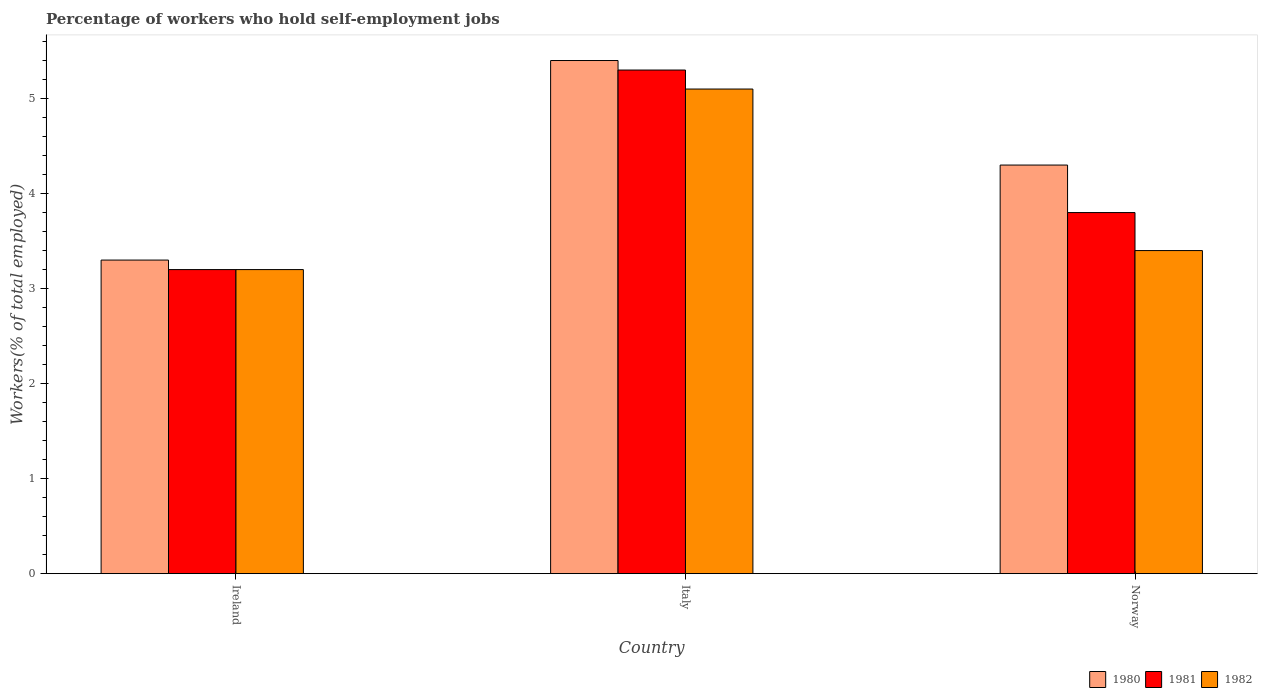Are the number of bars on each tick of the X-axis equal?
Offer a terse response. Yes. What is the label of the 3rd group of bars from the left?
Provide a succinct answer. Norway. In how many cases, is the number of bars for a given country not equal to the number of legend labels?
Keep it short and to the point. 0. What is the percentage of self-employed workers in 1982 in Italy?
Offer a terse response. 5.1. Across all countries, what is the maximum percentage of self-employed workers in 1980?
Keep it short and to the point. 5.4. Across all countries, what is the minimum percentage of self-employed workers in 1980?
Give a very brief answer. 3.3. In which country was the percentage of self-employed workers in 1982 maximum?
Your answer should be very brief. Italy. In which country was the percentage of self-employed workers in 1981 minimum?
Provide a short and direct response. Ireland. What is the total percentage of self-employed workers in 1982 in the graph?
Give a very brief answer. 11.7. What is the difference between the percentage of self-employed workers in 1981 in Ireland and that in Italy?
Provide a short and direct response. -2.1. What is the difference between the percentage of self-employed workers in 1981 in Ireland and the percentage of self-employed workers in 1980 in Norway?
Offer a very short reply. -1.1. What is the average percentage of self-employed workers in 1982 per country?
Your response must be concise. 3.9. What is the difference between the percentage of self-employed workers of/in 1980 and percentage of self-employed workers of/in 1981 in Norway?
Make the answer very short. 0.5. In how many countries, is the percentage of self-employed workers in 1981 greater than 0.6000000000000001 %?
Your response must be concise. 3. What is the ratio of the percentage of self-employed workers in 1980 in Ireland to that in Norway?
Offer a very short reply. 0.77. Is the percentage of self-employed workers in 1982 in Ireland less than that in Norway?
Provide a short and direct response. Yes. Is the difference between the percentage of self-employed workers in 1980 in Italy and Norway greater than the difference between the percentage of self-employed workers in 1981 in Italy and Norway?
Make the answer very short. No. What is the difference between the highest and the second highest percentage of self-employed workers in 1980?
Your answer should be compact. -1. What is the difference between the highest and the lowest percentage of self-employed workers in 1982?
Offer a terse response. 1.9. What does the 2nd bar from the right in Italy represents?
Your response must be concise. 1981. Is it the case that in every country, the sum of the percentage of self-employed workers in 1981 and percentage of self-employed workers in 1982 is greater than the percentage of self-employed workers in 1980?
Provide a succinct answer. Yes. How many countries are there in the graph?
Provide a succinct answer. 3. Are the values on the major ticks of Y-axis written in scientific E-notation?
Your answer should be compact. No. Does the graph contain any zero values?
Provide a short and direct response. No. How many legend labels are there?
Your answer should be compact. 3. How are the legend labels stacked?
Give a very brief answer. Horizontal. What is the title of the graph?
Provide a succinct answer. Percentage of workers who hold self-employment jobs. What is the label or title of the X-axis?
Your response must be concise. Country. What is the label or title of the Y-axis?
Keep it short and to the point. Workers(% of total employed). What is the Workers(% of total employed) in 1980 in Ireland?
Ensure brevity in your answer.  3.3. What is the Workers(% of total employed) of 1981 in Ireland?
Offer a terse response. 3.2. What is the Workers(% of total employed) in 1982 in Ireland?
Provide a succinct answer. 3.2. What is the Workers(% of total employed) in 1980 in Italy?
Keep it short and to the point. 5.4. What is the Workers(% of total employed) of 1981 in Italy?
Provide a short and direct response. 5.3. What is the Workers(% of total employed) in 1982 in Italy?
Ensure brevity in your answer.  5.1. What is the Workers(% of total employed) in 1980 in Norway?
Keep it short and to the point. 4.3. What is the Workers(% of total employed) in 1981 in Norway?
Ensure brevity in your answer.  3.8. What is the Workers(% of total employed) in 1982 in Norway?
Give a very brief answer. 3.4. Across all countries, what is the maximum Workers(% of total employed) of 1980?
Offer a very short reply. 5.4. Across all countries, what is the maximum Workers(% of total employed) in 1981?
Your answer should be compact. 5.3. Across all countries, what is the maximum Workers(% of total employed) of 1982?
Provide a short and direct response. 5.1. Across all countries, what is the minimum Workers(% of total employed) of 1980?
Your answer should be compact. 3.3. Across all countries, what is the minimum Workers(% of total employed) of 1981?
Offer a very short reply. 3.2. Across all countries, what is the minimum Workers(% of total employed) of 1982?
Keep it short and to the point. 3.2. What is the total Workers(% of total employed) in 1982 in the graph?
Make the answer very short. 11.7. What is the difference between the Workers(% of total employed) of 1980 in Ireland and that in Italy?
Ensure brevity in your answer.  -2.1. What is the difference between the Workers(% of total employed) of 1981 in Ireland and that in Italy?
Offer a terse response. -2.1. What is the difference between the Workers(% of total employed) of 1980 in Ireland and that in Norway?
Offer a terse response. -1. What is the difference between the Workers(% of total employed) of 1980 in Italy and that in Norway?
Offer a terse response. 1.1. What is the difference between the Workers(% of total employed) of 1980 in Ireland and the Workers(% of total employed) of 1981 in Italy?
Your answer should be very brief. -2. What is the difference between the Workers(% of total employed) of 1980 in Ireland and the Workers(% of total employed) of 1982 in Italy?
Give a very brief answer. -1.8. What is the difference between the Workers(% of total employed) in 1981 in Ireland and the Workers(% of total employed) in 1982 in Italy?
Make the answer very short. -1.9. What is the difference between the Workers(% of total employed) in 1980 in Ireland and the Workers(% of total employed) in 1981 in Norway?
Provide a short and direct response. -0.5. What is the difference between the Workers(% of total employed) of 1981 in Ireland and the Workers(% of total employed) of 1982 in Norway?
Offer a terse response. -0.2. What is the difference between the Workers(% of total employed) in 1980 in Italy and the Workers(% of total employed) in 1981 in Norway?
Your answer should be compact. 1.6. What is the difference between the Workers(% of total employed) of 1981 in Italy and the Workers(% of total employed) of 1982 in Norway?
Offer a terse response. 1.9. What is the average Workers(% of total employed) of 1980 per country?
Offer a terse response. 4.33. What is the average Workers(% of total employed) in 1981 per country?
Provide a succinct answer. 4.1. What is the difference between the Workers(% of total employed) of 1980 and Workers(% of total employed) of 1981 in Ireland?
Your answer should be compact. 0.1. What is the difference between the Workers(% of total employed) in 1980 and Workers(% of total employed) in 1981 in Italy?
Ensure brevity in your answer.  0.1. What is the difference between the Workers(% of total employed) in 1980 and Workers(% of total employed) in 1982 in Italy?
Offer a terse response. 0.3. What is the difference between the Workers(% of total employed) of 1980 and Workers(% of total employed) of 1981 in Norway?
Offer a terse response. 0.5. What is the difference between the Workers(% of total employed) of 1980 and Workers(% of total employed) of 1982 in Norway?
Your answer should be compact. 0.9. What is the ratio of the Workers(% of total employed) in 1980 in Ireland to that in Italy?
Your response must be concise. 0.61. What is the ratio of the Workers(% of total employed) of 1981 in Ireland to that in Italy?
Provide a short and direct response. 0.6. What is the ratio of the Workers(% of total employed) in 1982 in Ireland to that in Italy?
Offer a terse response. 0.63. What is the ratio of the Workers(% of total employed) in 1980 in Ireland to that in Norway?
Your answer should be compact. 0.77. What is the ratio of the Workers(% of total employed) of 1981 in Ireland to that in Norway?
Make the answer very short. 0.84. What is the ratio of the Workers(% of total employed) of 1980 in Italy to that in Norway?
Keep it short and to the point. 1.26. What is the ratio of the Workers(% of total employed) in 1981 in Italy to that in Norway?
Provide a short and direct response. 1.39. What is the ratio of the Workers(% of total employed) in 1982 in Italy to that in Norway?
Ensure brevity in your answer.  1.5. What is the difference between the highest and the second highest Workers(% of total employed) in 1980?
Offer a very short reply. 1.1. What is the difference between the highest and the lowest Workers(% of total employed) of 1980?
Provide a short and direct response. 2.1. What is the difference between the highest and the lowest Workers(% of total employed) in 1981?
Your answer should be very brief. 2.1. 